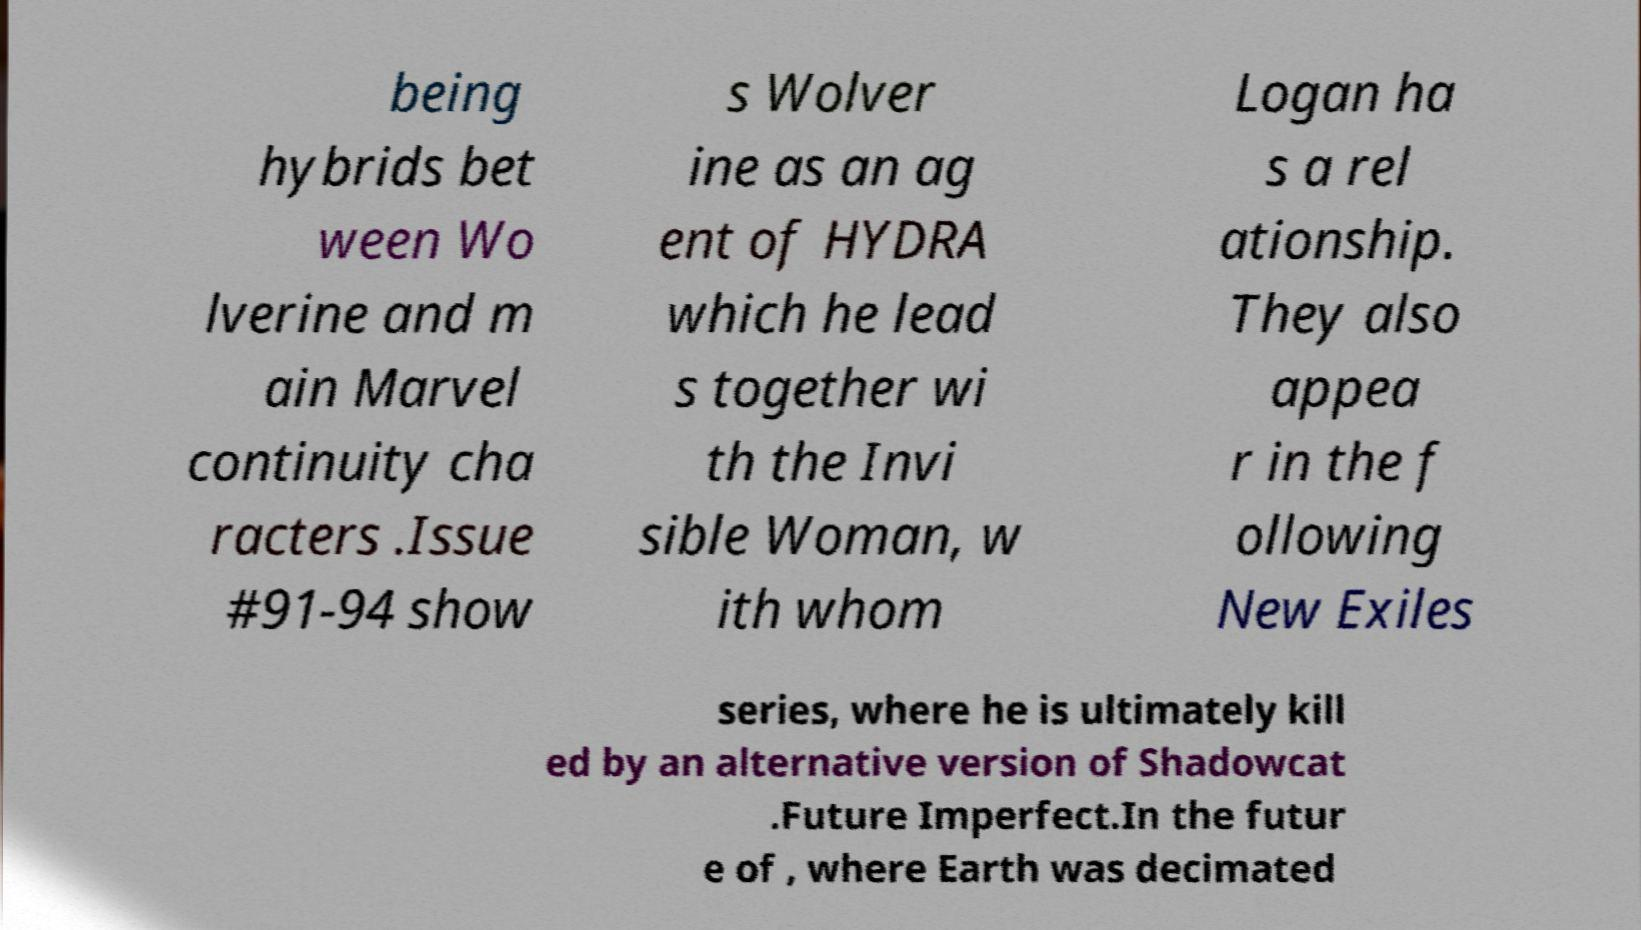There's text embedded in this image that I need extracted. Can you transcribe it verbatim? being hybrids bet ween Wo lverine and m ain Marvel continuity cha racters .Issue #91-94 show s Wolver ine as an ag ent of HYDRA which he lead s together wi th the Invi sible Woman, w ith whom Logan ha s a rel ationship. They also appea r in the f ollowing New Exiles series, where he is ultimately kill ed by an alternative version of Shadowcat .Future Imperfect.In the futur e of , where Earth was decimated 